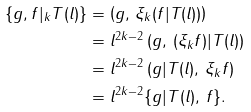Convert formula to latex. <formula><loc_0><loc_0><loc_500><loc_500>\{ g , f | _ { k } T ( l ) \} & = \left ( g , \, \xi _ { k } ( f | T ( l ) ) \right ) \\ & = l ^ { 2 k - 2 } \left ( g , \, ( \xi _ { k } f ) | T ( l ) \right ) \\ & = l ^ { 2 k - 2 } \left ( g | T ( l ) , \, \xi _ { k } f \right ) \\ & = l ^ { 2 k - 2 } \{ g | T ( l ) , \, f \} .</formula> 